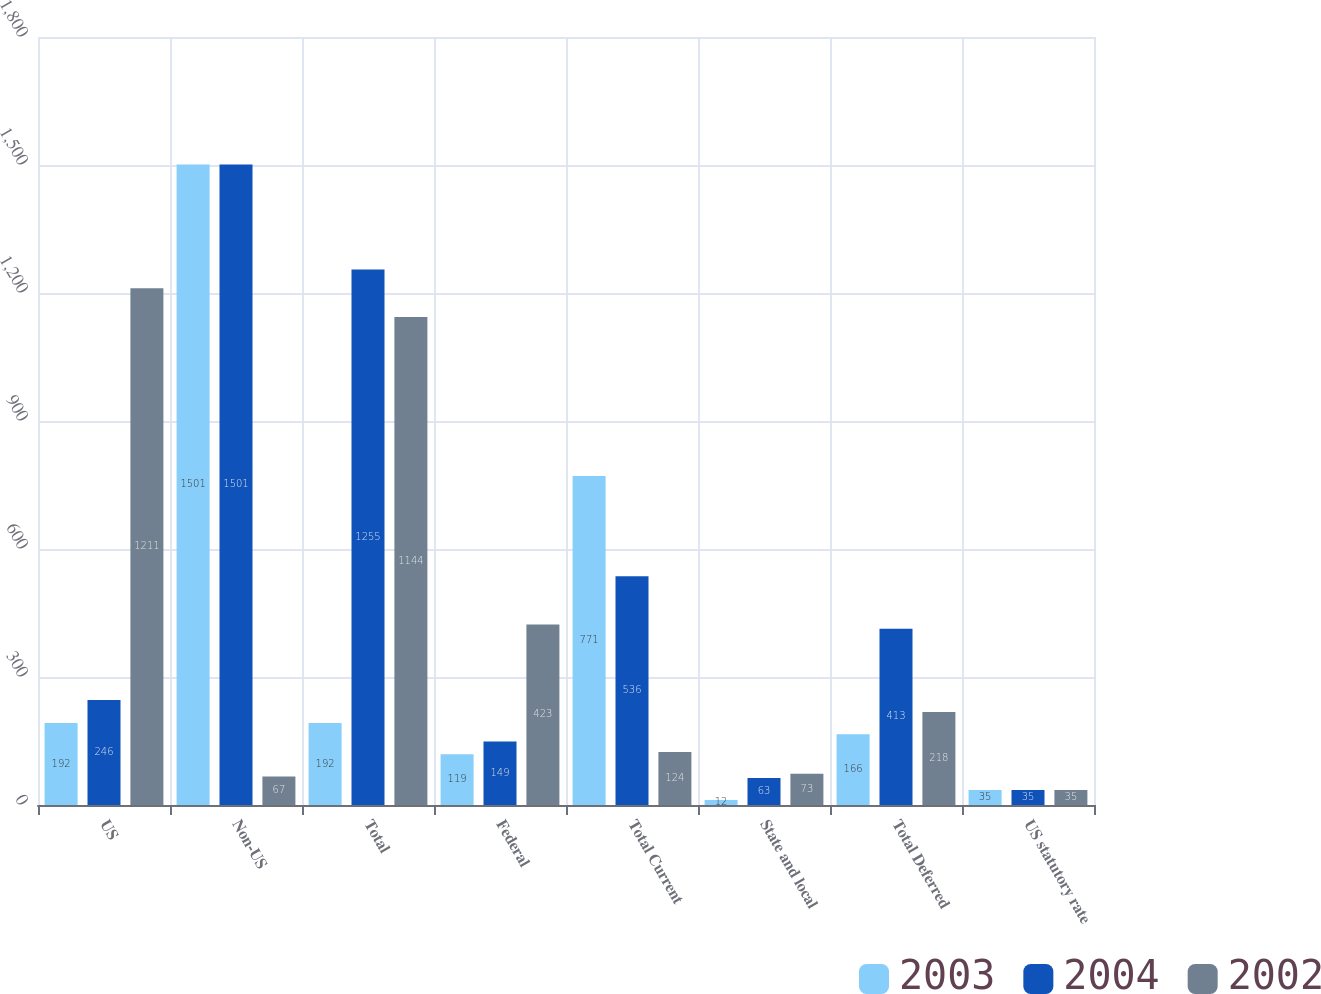Convert chart. <chart><loc_0><loc_0><loc_500><loc_500><stacked_bar_chart><ecel><fcel>US<fcel>Non-US<fcel>Total<fcel>Federal<fcel>Total Current<fcel>State and local<fcel>Total Deferred<fcel>US statutory rate<nl><fcel>2003<fcel>192<fcel>1501<fcel>192<fcel>119<fcel>771<fcel>12<fcel>166<fcel>35<nl><fcel>2004<fcel>246<fcel>1501<fcel>1255<fcel>149<fcel>536<fcel>63<fcel>413<fcel>35<nl><fcel>2002<fcel>1211<fcel>67<fcel>1144<fcel>423<fcel>124<fcel>73<fcel>218<fcel>35<nl></chart> 